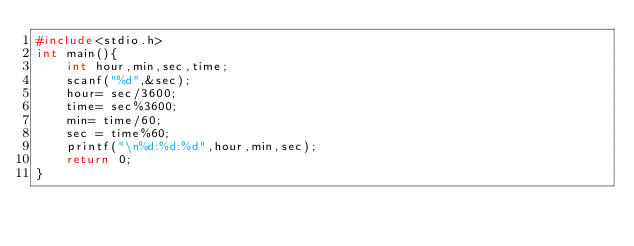<code> <loc_0><loc_0><loc_500><loc_500><_C_>#include<stdio.h>
int main(){
    int hour,min,sec,time;
    scanf("%d",&sec);
    hour= sec/3600;
    time= sec%3600;
    min= time/60;
    sec = time%60;
    printf("\n%d:%d:%d",hour,min,sec);
    return 0;
}</code> 